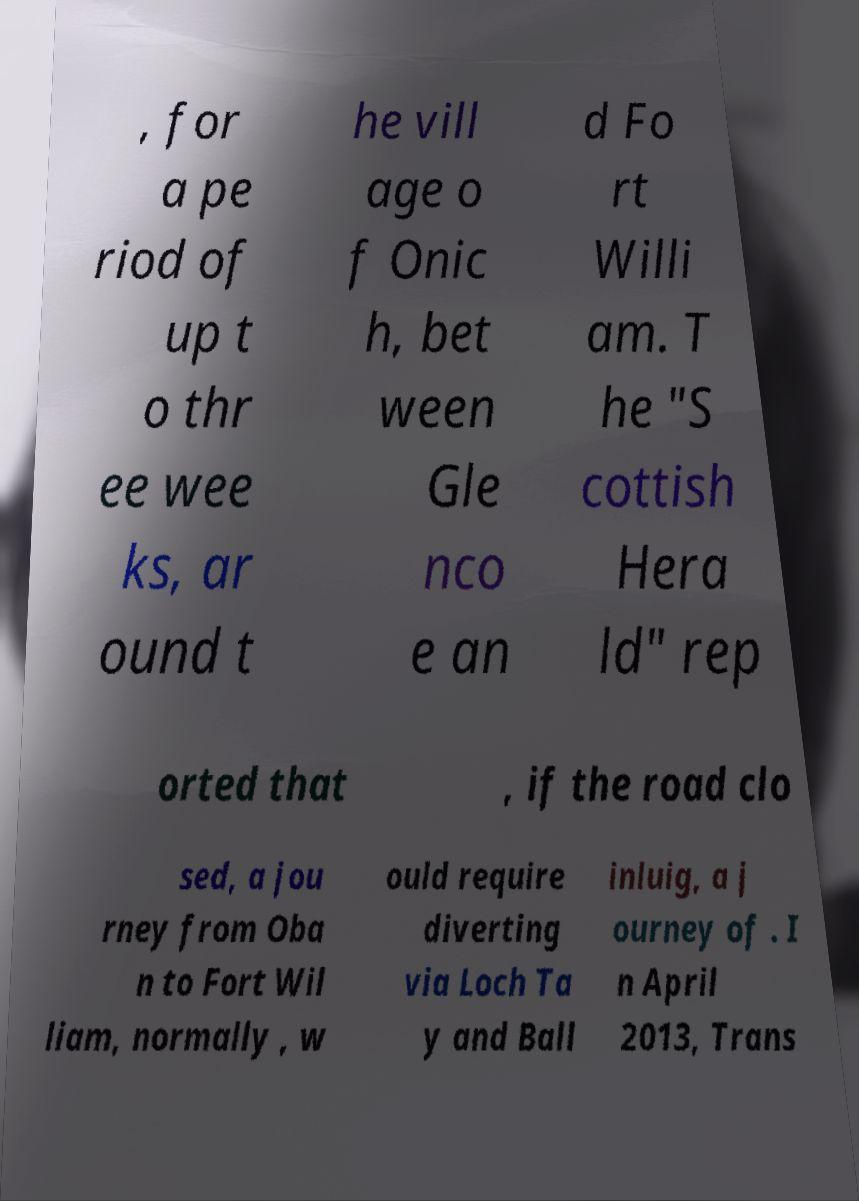What messages or text are displayed in this image? I need them in a readable, typed format. , for a pe riod of up t o thr ee wee ks, ar ound t he vill age o f Onic h, bet ween Gle nco e an d Fo rt Willi am. T he "S cottish Hera ld" rep orted that , if the road clo sed, a jou rney from Oba n to Fort Wil liam, normally , w ould require diverting via Loch Ta y and Ball inluig, a j ourney of . I n April 2013, Trans 